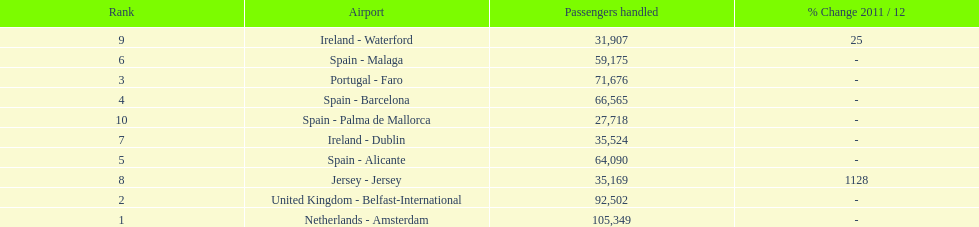Which airport had more passengers handled than the united kingdom? Netherlands - Amsterdam. 